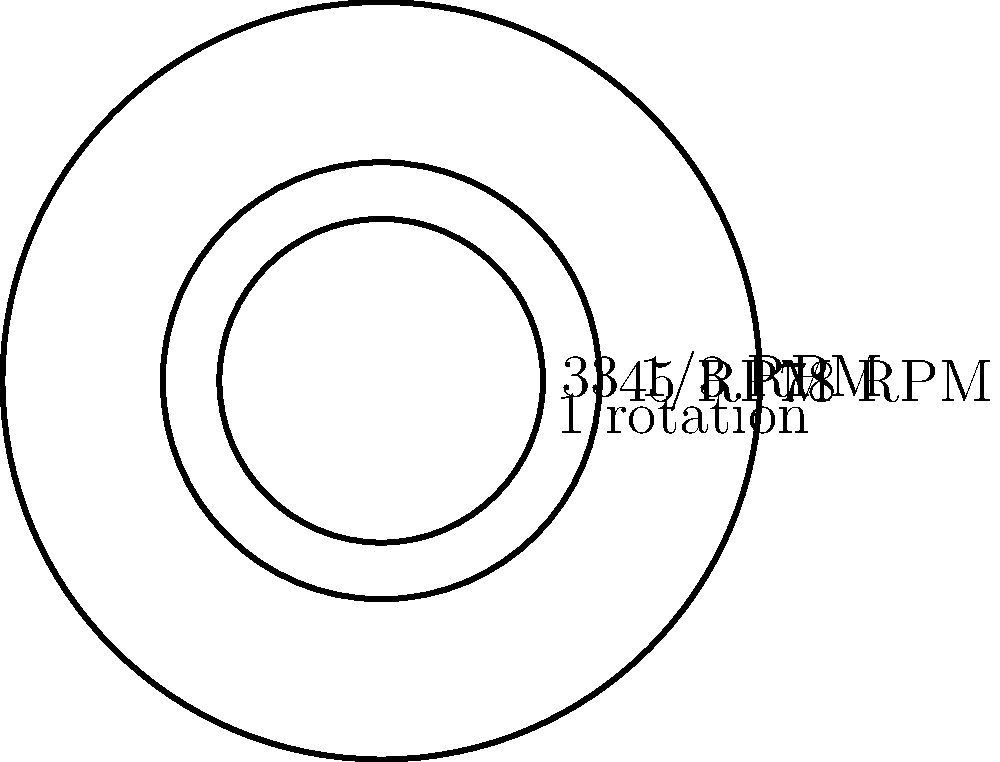In the diagram, three circles represent the rotation of vinyl records at different speeds relative to a 33 1/3 RPM record. If the 33 1/3 RPM record makes exactly one rotation, how many rotations would a 78 RPM record make in the same time? To solve this problem, we need to follow these steps:

1. Understand the relationship between RPM (Revolutions Per Minute) and rotation speed:
   - Higher RPM means faster rotation
   - The ratio of rotations will be proportional to the ratio of RPM values

2. Calculate the ratio of 78 RPM to 33 1/3 RPM:
   $$ \frac{78 \text{ RPM}}{33.33 \text{ RPM}} = 2.34 $$

3. Interpret the result:
   - This means that in the time it takes a 33 1/3 RPM record to make one rotation, a 78 RPM record will make 2.34 rotations

4. Verify with the diagram:
   - The outermost circle represents the 78 RPM record
   - It is indeed 2.34 times larger than the dashed circle representing one rotation

Therefore, while a 33 1/3 RPM record makes one rotation, a 78 RPM record will make 2.34 rotations in the same time.
Answer: 2.34 rotations 